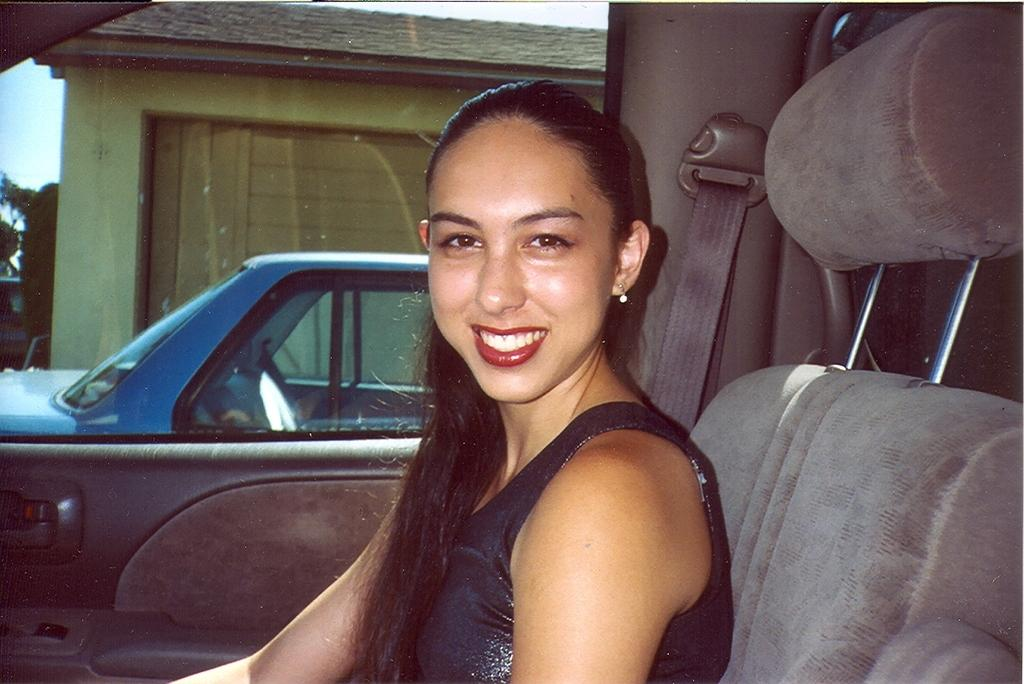Who is the main subject in the image? There is a woman in the image. What is the woman doing in the image? The woman is sitting on a car and smiling. Can you describe the background of the image? There is another car traveling in the background and a tree visible in the image. What type of thread is being used to sew the woman's smile in the image? There is no thread present in the image, and the woman's smile is not being sewn. 